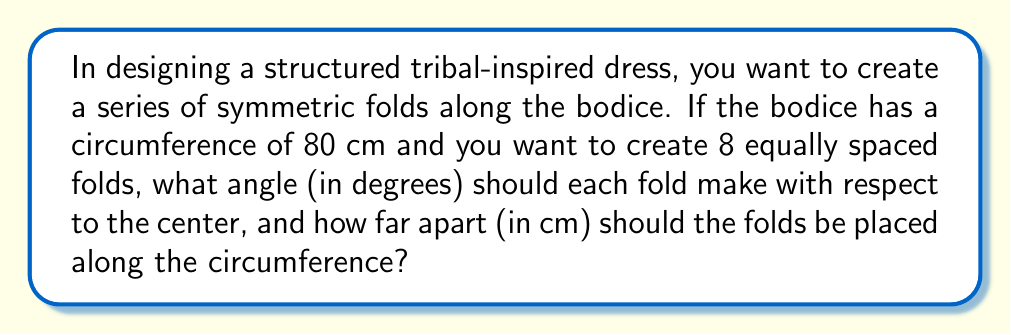Could you help me with this problem? Let's approach this problem step-by-step:

1. Angle calculation:
   - There are 8 folds, which means the circle (bodice circumference) will be divided into 8 equal parts.
   - The total angle in a circle is 360°.
   - The angle for each fold: $\theta = \frac{360°}{8} = 45°$

2. Distance between folds:
   - The circumference of the bodice is 80 cm.
   - We need to divide this circumference into 8 equal parts.
   - Distance between folds: $d = \frac{80\text{ cm}}{8} = 10\text{ cm}$

3. Visualization:
   [asy]
   import geometry;
   
   size(200);
   
   circle c = circle((0,0), 4);
   draw(c);
   
   for(int i = 0; i < 8; ++i) {
     draw((0,0)--4*dir(i*45), Arrow);
   }
   
   label("45°", (2,2), NE);
   label("10 cm", (0,-4.5), S);
   [/asy]

The diagram shows the circular bodice with 8 equally spaced folds. Each fold is represented by an arrow, making a 45° angle with its neighbors. The arc length between each fold is 10 cm.
Answer: 45°, 10 cm 